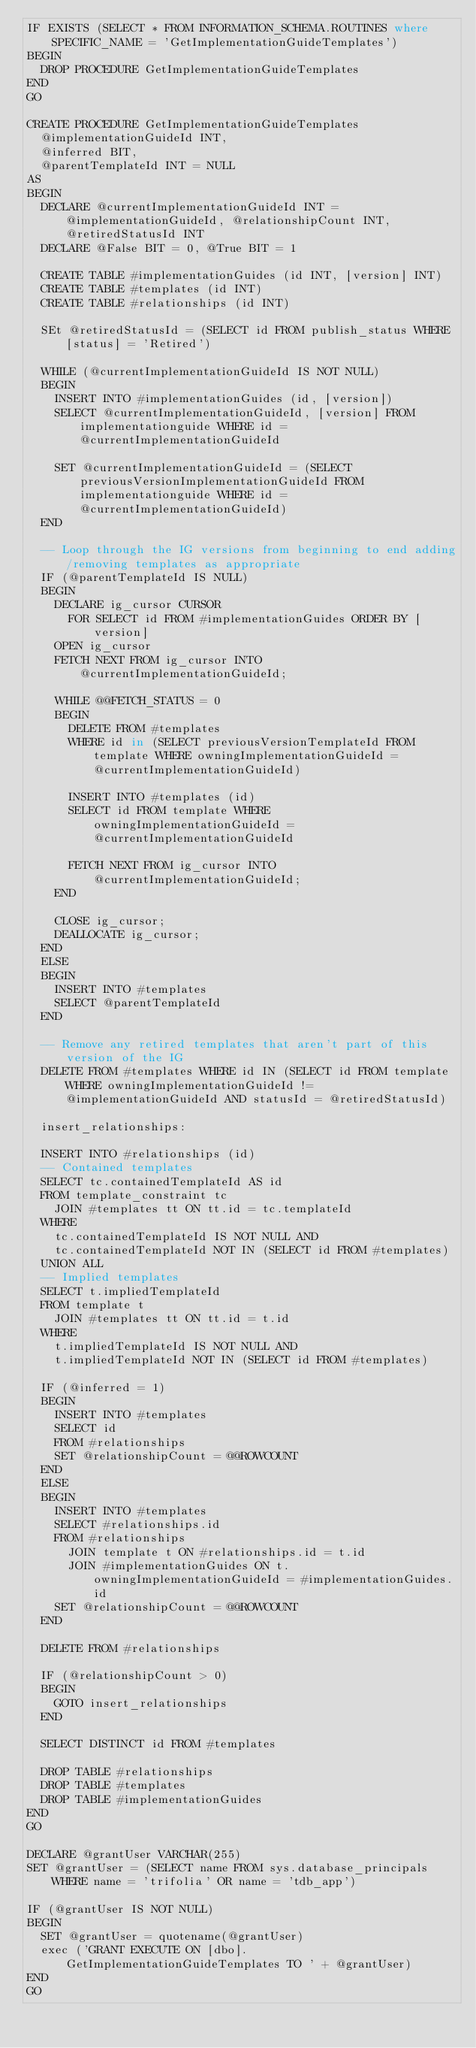Convert code to text. <code><loc_0><loc_0><loc_500><loc_500><_SQL_>IF EXISTS (SELECT * FROM INFORMATION_SCHEMA.ROUTINES where SPECIFIC_NAME = 'GetImplementationGuideTemplates')
BEGIN
	DROP PROCEDURE GetImplementationGuideTemplates
END
GO

CREATE PROCEDURE GetImplementationGuideTemplates
	@implementationGuideId INT,
	@inferred BIT,
	@parentTemplateId INT = NULL
AS
BEGIN
	DECLARE @currentImplementationGuideId INT = @implementationGuideId, @relationshipCount INT, @retiredStatusId INT
	DECLARE @False BIT = 0, @True BIT = 1

	CREATE TABLE #implementationGuides (id INT, [version] INT)
	CREATE TABLE #templates (id INT)
	CREATE TABLE #relationships (id INT)

	SEt @retiredStatusId = (SELECT id FROM publish_status WHERE [status] = 'Retired')

	WHILE (@currentImplementationGuideId IS NOT NULL)
	BEGIN
		INSERT INTO #implementationGuides (id, [version])
		SELECT @currentImplementationGuideId, [version] FROM implementationguide WHERE id = @currentImplementationGuideId

		SET @currentImplementationGuideId = (SELECT previousVersionImplementationGuideId FROM implementationguide WHERE id = @currentImplementationGuideId)
	END

	-- Loop through the IG versions from beginning to end adding/removing templates as appropriate
	IF (@parentTemplateId IS NULL)
	BEGIN
		DECLARE ig_cursor CURSOR
			FOR SELECT id FROM #implementationGuides ORDER BY [version]
		OPEN ig_cursor
		FETCH NEXT FROM ig_cursor INTO @currentImplementationGuideId;

		WHILE @@FETCH_STATUS = 0
		BEGIN
			DELETE FROM #templates
			WHERE id in (SELECT previousVersionTemplateId FROM template WHERE owningImplementationGuideId = @currentImplementationGuideId)

			INSERT INTO #templates (id)
			SELECT id FROM template WHERE owningImplementationGuideId = @currentImplementationGuideId

			FETCH NEXT FROM ig_cursor INTO @currentImplementationGuideId;
		END

		CLOSE ig_cursor;
		DEALLOCATE ig_cursor;
	END
	ELSE
	BEGIN
		INSERT INTO #templates
		SELECT @parentTemplateId
	END

	-- Remove any retired templates that aren't part of this version of the IG
	DELETE FROM #templates WHERE id IN (SELECT id FROM template WHERE owningImplementationGuideId != @implementationGuideId AND statusId = @retiredStatusId)

	insert_relationships:

	INSERT INTO #relationships (id)
	-- Contained templates
	SELECT tc.containedTemplateId AS id
	FROM template_constraint tc
		JOIN #templates tt ON tt.id = tc.templateId
	WHERE
		tc.containedTemplateId IS NOT NULL AND
		tc.containedTemplateId NOT IN (SELECT id FROM #templates)
	UNION ALL
	-- Implied templates
	SELECT t.impliedTemplateId
	FROM template t
		JOIN #templates tt ON tt.id = t.id
	WHERE
		t.impliedTemplateId IS NOT NULL AND
		t.impliedTemplateId NOT IN (SELECT id FROM #templates)

	IF (@inferred = 1)
	BEGIN
		INSERT INTO #templates
		SELECT id
		FROM #relationships
		SET @relationshipCount = @@ROWCOUNT
	END
	ELSE
	BEGIN
		INSERT INTO #templates
		SELECT #relationships.id
		FROM #relationships
			JOIN template t ON #relationships.id = t.id
			JOIN #implementationGuides ON t.owningImplementationGuideId = #implementationGuides.id
		SET @relationshipCount = @@ROWCOUNT
	END

	DELETE FROM #relationships

	IF (@relationshipCount > 0)
	BEGIN
		GOTO insert_relationships
	END

	SELECT DISTINCT id FROM #templates

	DROP TABLE #relationships
	DROP TABLE #templates
	DROP TABLE #implementationGuides
END
GO

DECLARE @grantUser VARCHAR(255)
SET @grantUser = (SELECT name FROM sys.database_principals WHERE name = 'trifolia' OR name = 'tdb_app')

IF (@grantUser IS NOT NULL)
BEGIN
	SET @grantUser = quotename(@grantUser)
	exec ('GRANT EXECUTE ON [dbo].GetImplementationGuideTemplates TO ' + @grantUser)
END
GO</code> 